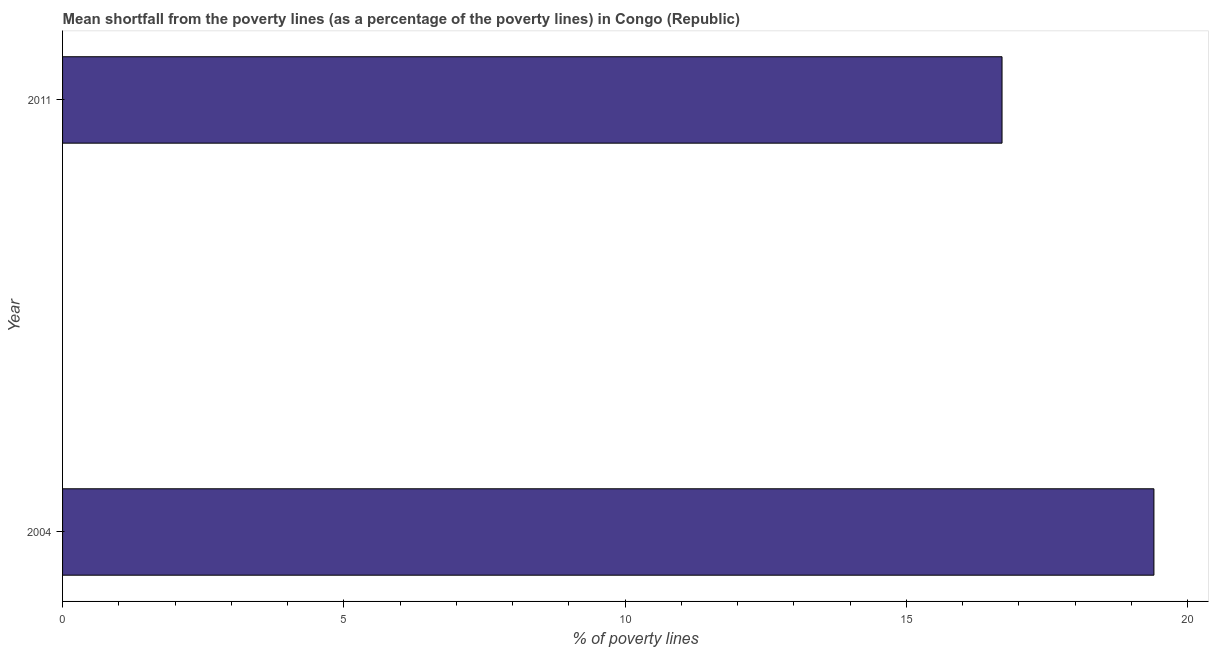What is the title of the graph?
Your answer should be very brief. Mean shortfall from the poverty lines (as a percentage of the poverty lines) in Congo (Republic). What is the label or title of the X-axis?
Offer a very short reply. % of poverty lines. What is the poverty gap at national poverty lines in 2011?
Make the answer very short. 16.7. Across all years, what is the maximum poverty gap at national poverty lines?
Provide a short and direct response. 19.4. Across all years, what is the minimum poverty gap at national poverty lines?
Keep it short and to the point. 16.7. What is the sum of the poverty gap at national poverty lines?
Your response must be concise. 36.1. What is the average poverty gap at national poverty lines per year?
Offer a terse response. 18.05. What is the median poverty gap at national poverty lines?
Ensure brevity in your answer.  18.05. Do a majority of the years between 2011 and 2004 (inclusive) have poverty gap at national poverty lines greater than 8 %?
Offer a terse response. No. What is the ratio of the poverty gap at national poverty lines in 2004 to that in 2011?
Keep it short and to the point. 1.16. In how many years, is the poverty gap at national poverty lines greater than the average poverty gap at national poverty lines taken over all years?
Provide a succinct answer. 1. How many bars are there?
Your response must be concise. 2. Are all the bars in the graph horizontal?
Offer a very short reply. Yes. What is the difference between two consecutive major ticks on the X-axis?
Offer a terse response. 5. Are the values on the major ticks of X-axis written in scientific E-notation?
Provide a short and direct response. No. What is the difference between the % of poverty lines in 2004 and 2011?
Your response must be concise. 2.7. What is the ratio of the % of poverty lines in 2004 to that in 2011?
Keep it short and to the point. 1.16. 